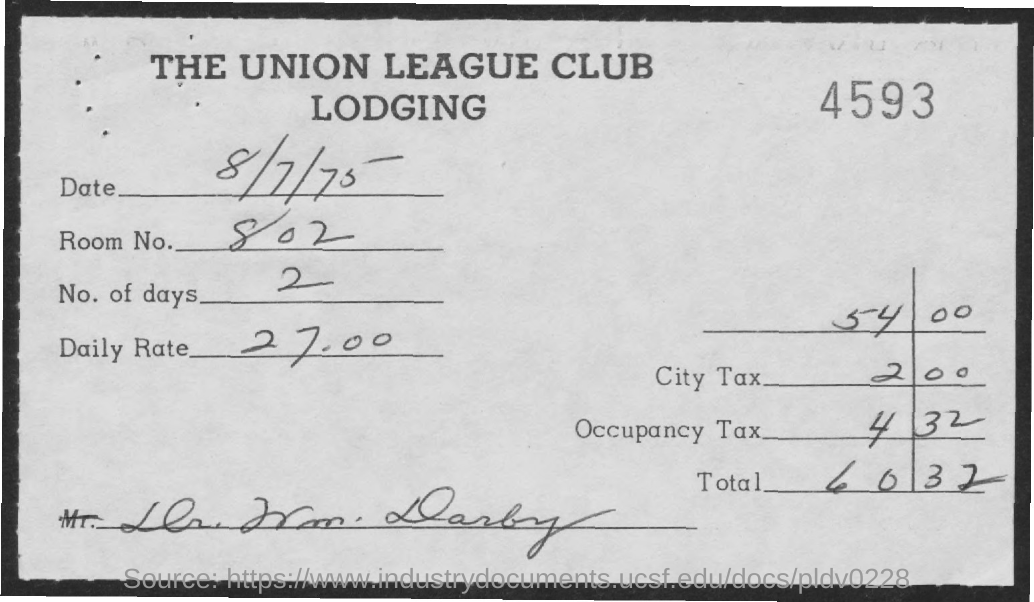What is the first title in the document?
Your answer should be compact. THE UNION LEAGUE CLUB. What is the room number?
Ensure brevity in your answer.  802. What is the number of days?
Offer a terse response. 2. What is the daily rate?
Your answer should be compact. 27.00. What is the number at the top right of the document?
Give a very brief answer. 4593. What is the total?
Offer a terse response. 60.32. What is the city tax?
Your answer should be very brief. 2 00. 